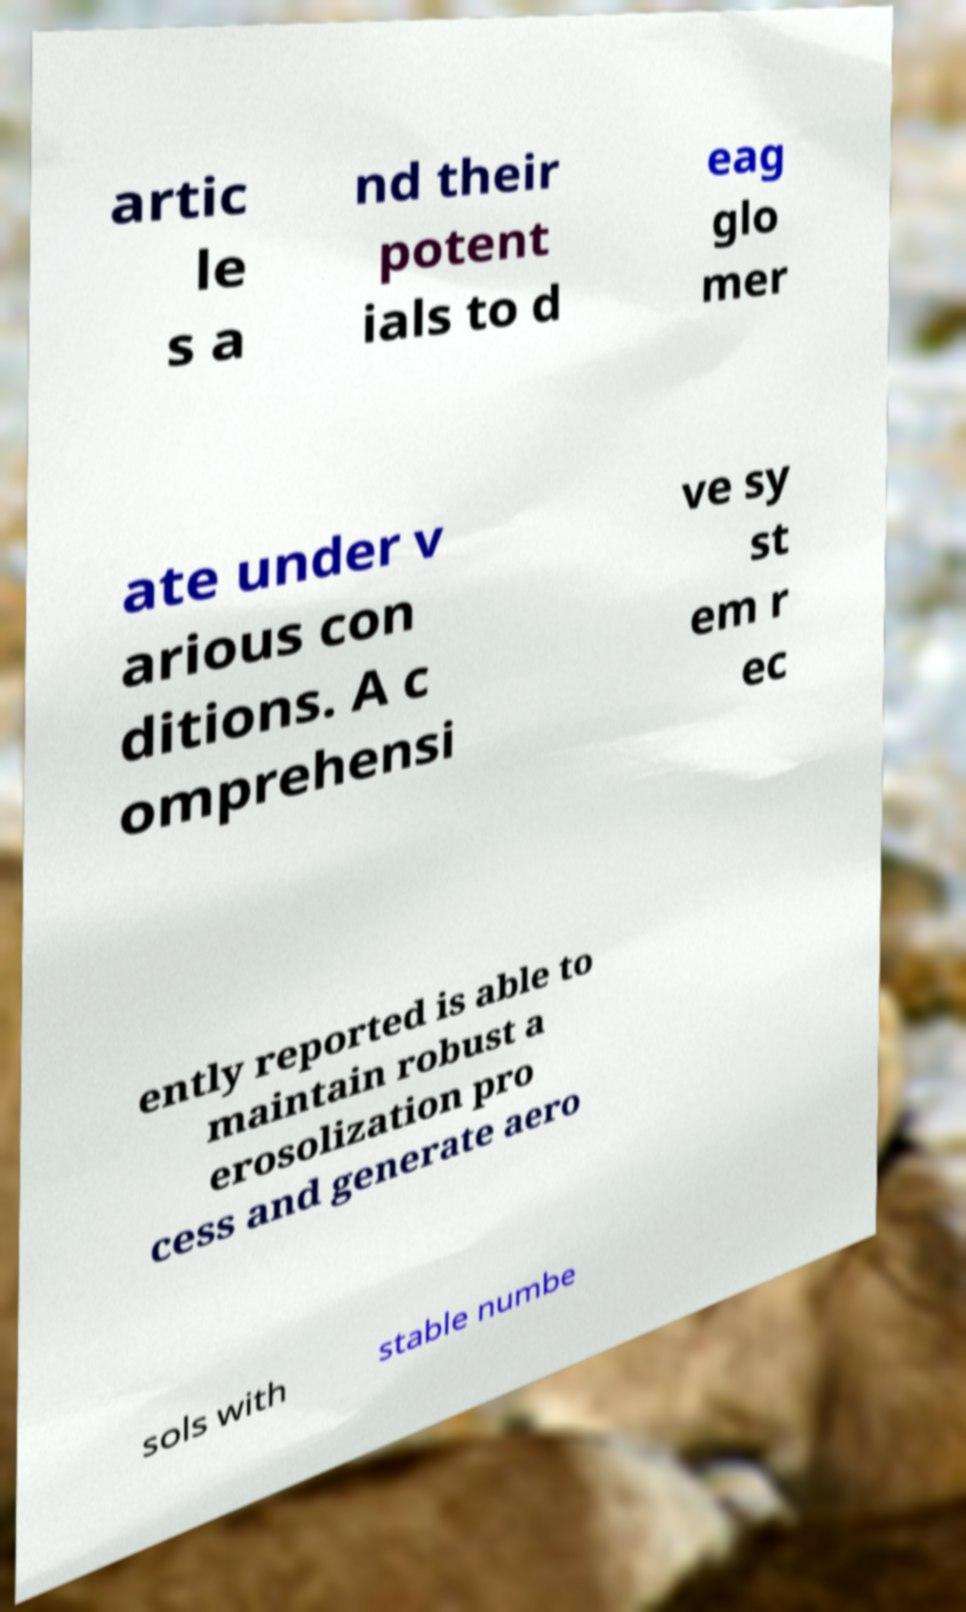I need the written content from this picture converted into text. Can you do that? artic le s a nd their potent ials to d eag glo mer ate under v arious con ditions. A c omprehensi ve sy st em r ec ently reported is able to maintain robust a erosolization pro cess and generate aero sols with stable numbe 